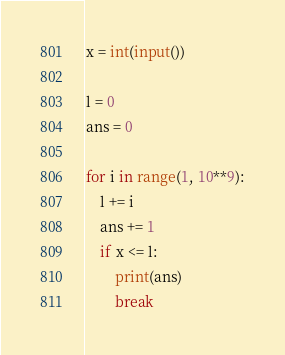Convert code to text. <code><loc_0><loc_0><loc_500><loc_500><_Python_>x = int(input())

l = 0
ans = 0

for i in range(1, 10**9):
    l += i
    ans += 1
    if x <= l:
        print(ans)
        break</code> 